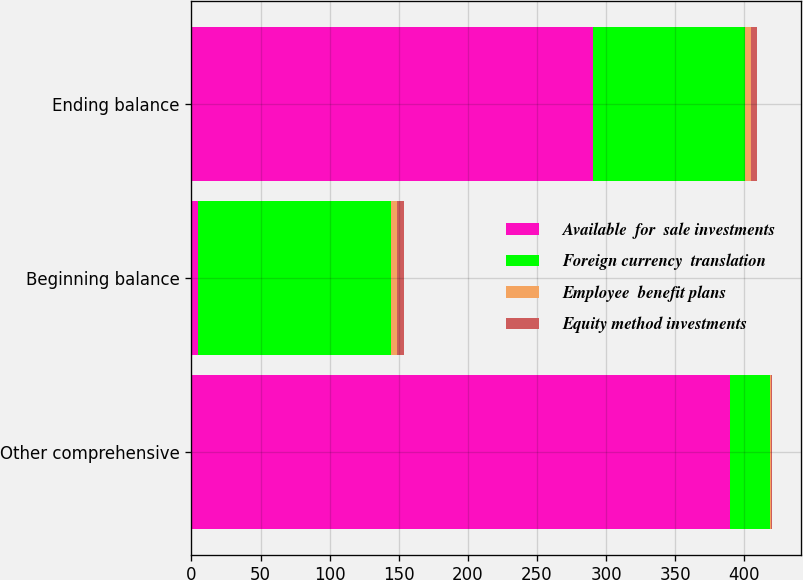Convert chart to OTSL. <chart><loc_0><loc_0><loc_500><loc_500><stacked_bar_chart><ecel><fcel>Other comprehensive<fcel>Beginning balance<fcel>Ending balance<nl><fcel>Available  for  sale investments<fcel>389.4<fcel>5<fcel>290.5<nl><fcel>Foreign currency  translation<fcel>29.5<fcel>139.2<fcel>109.7<nl><fcel>Employee  benefit plans<fcel>0.5<fcel>4.8<fcel>4.3<nl><fcel>Equity method investments<fcel>0.3<fcel>5<fcel>4.7<nl></chart> 